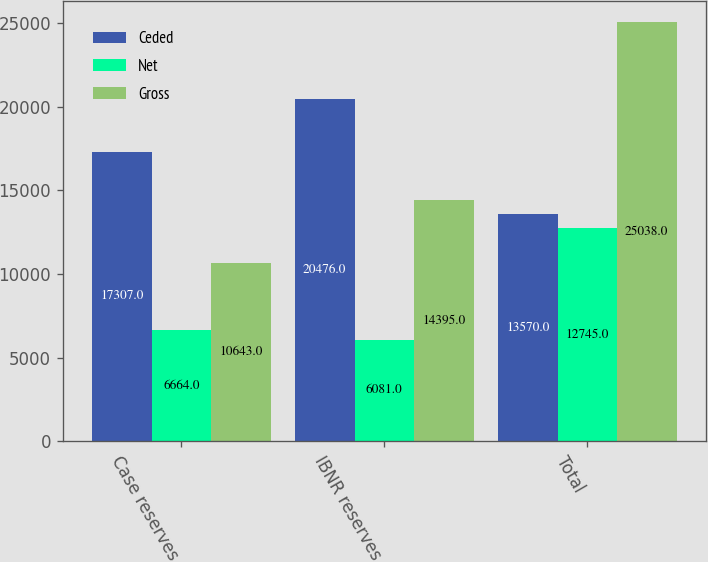Convert chart to OTSL. <chart><loc_0><loc_0><loc_500><loc_500><stacked_bar_chart><ecel><fcel>Case reserves<fcel>IBNR reserves<fcel>Total<nl><fcel>Ceded<fcel>17307<fcel>20476<fcel>13570<nl><fcel>Net<fcel>6664<fcel>6081<fcel>12745<nl><fcel>Gross<fcel>10643<fcel>14395<fcel>25038<nl></chart> 